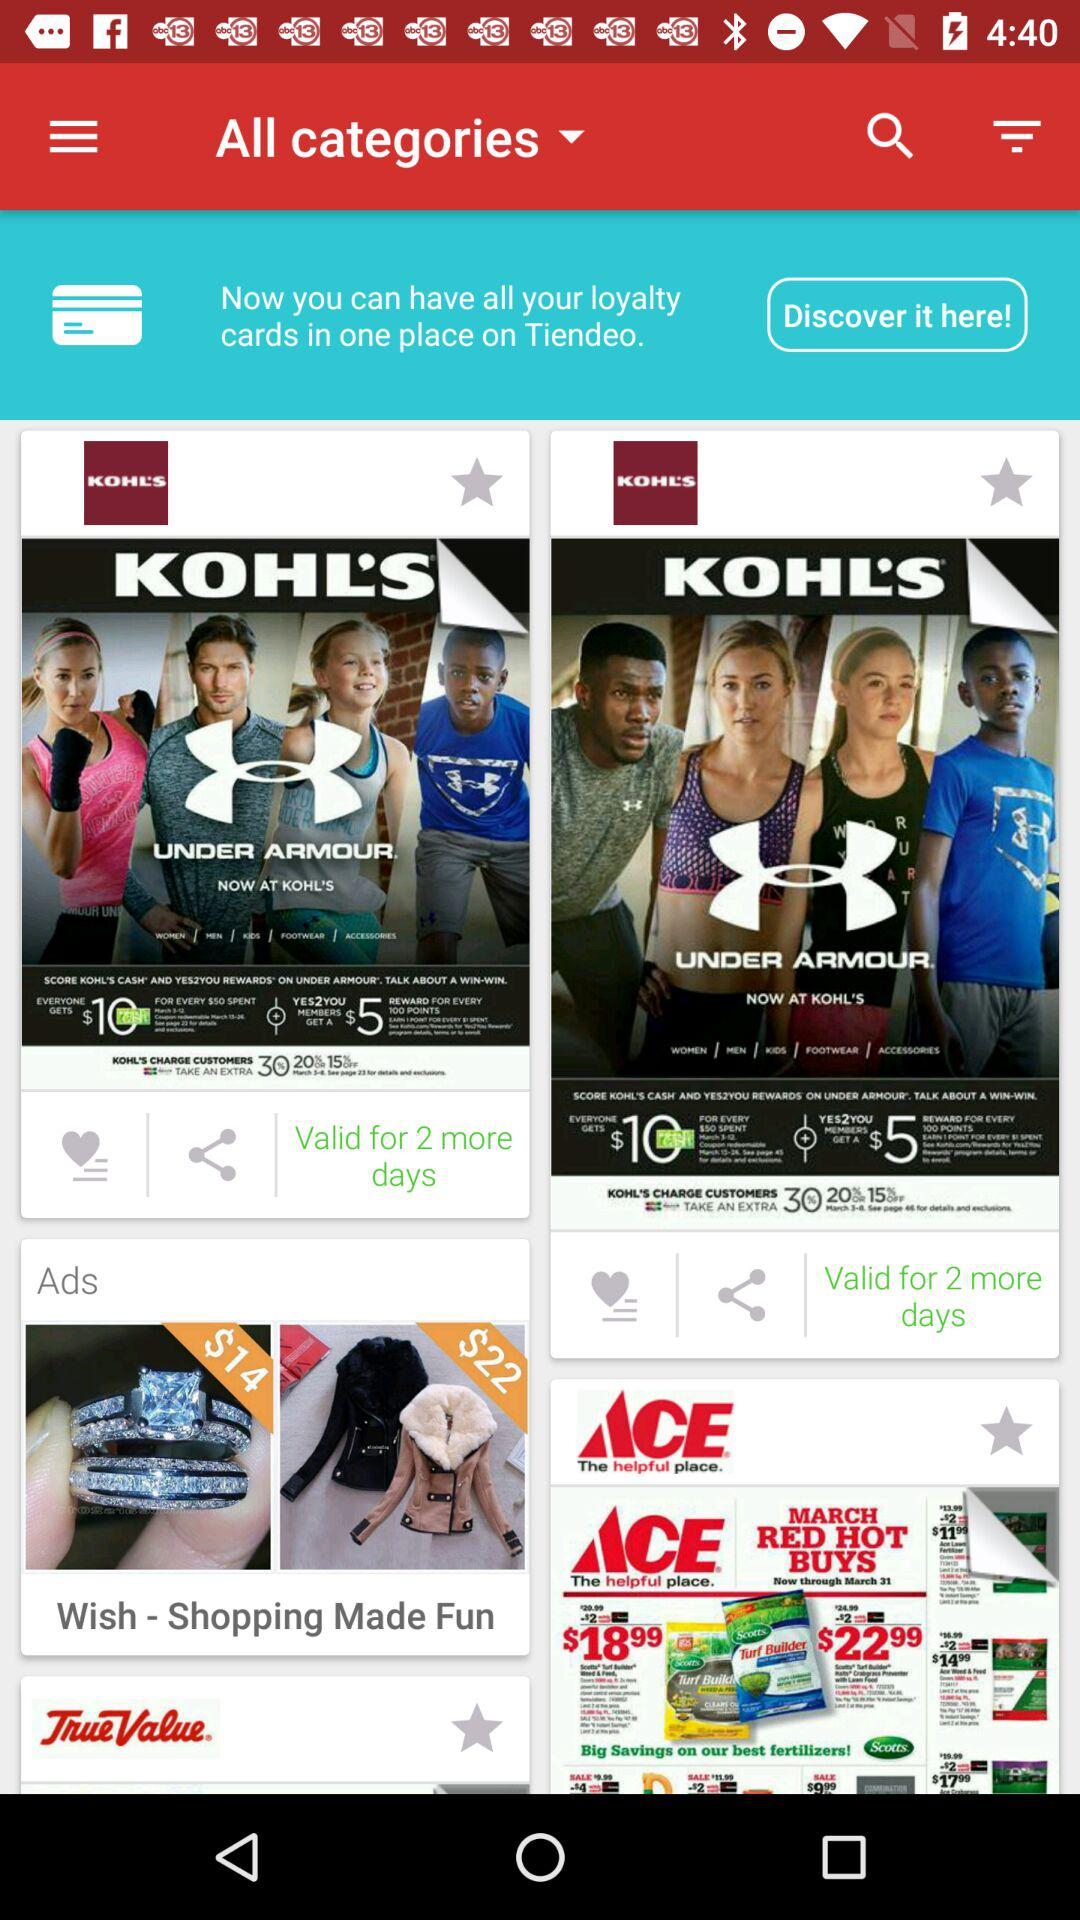What price is mentioned in the advertisement? The prices mentioned in the advertisement are $14 and $22. 